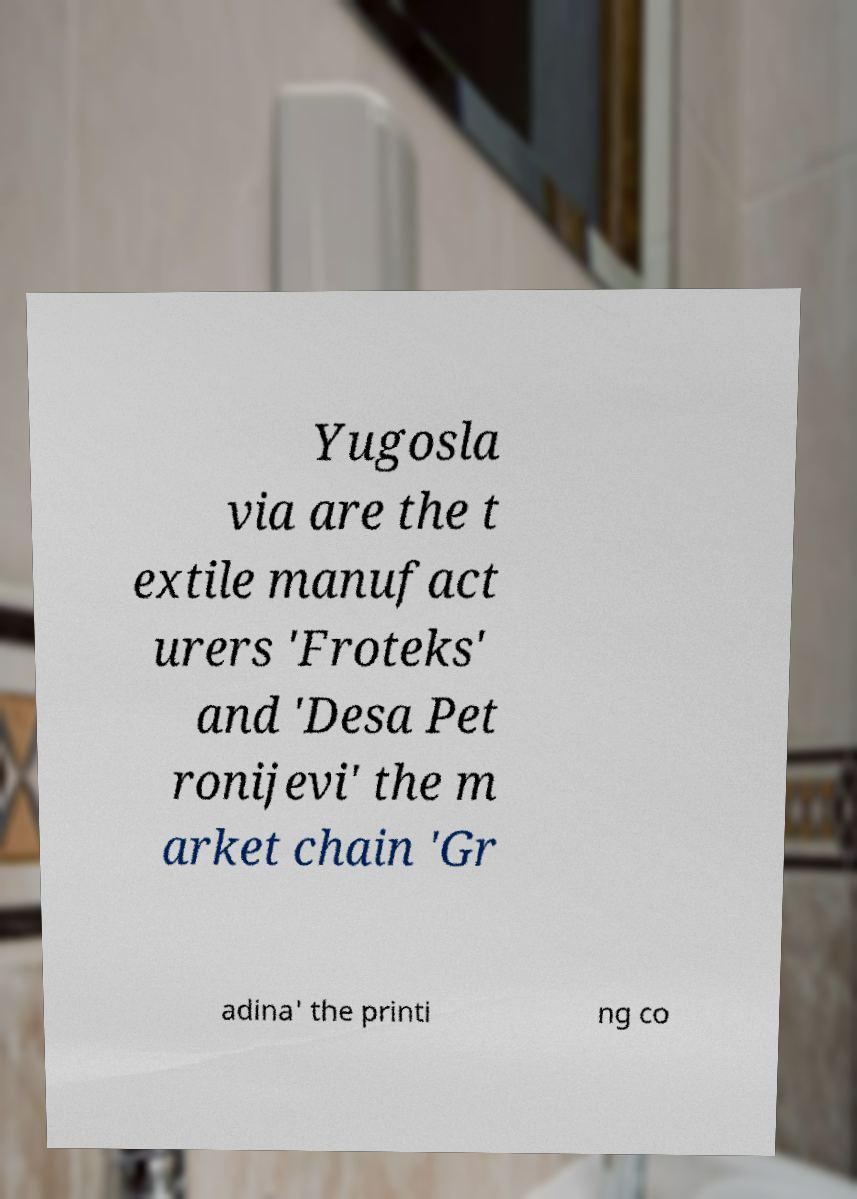There's text embedded in this image that I need extracted. Can you transcribe it verbatim? Yugosla via are the t extile manufact urers 'Froteks' and 'Desa Pet ronijevi' the m arket chain 'Gr adina' the printi ng co 